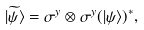<formula> <loc_0><loc_0><loc_500><loc_500>| \widetilde { \psi } \rangle = \sigma ^ { y } \otimes \sigma ^ { y } ( | \psi \rangle ) ^ { * } ,</formula> 